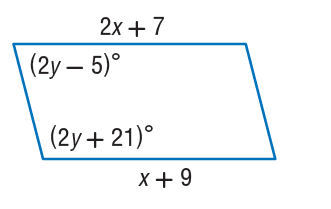Question: Find x so that the quadrilateral is a parallelogram.
Choices:
A. 2
B. 4
C. 9
D. 11
Answer with the letter. Answer: A Question: Find y so that the quadrilateral is a parallelogram.
Choices:
A. 9
B. 20
C. 21
D. 41
Answer with the letter. Answer: D 